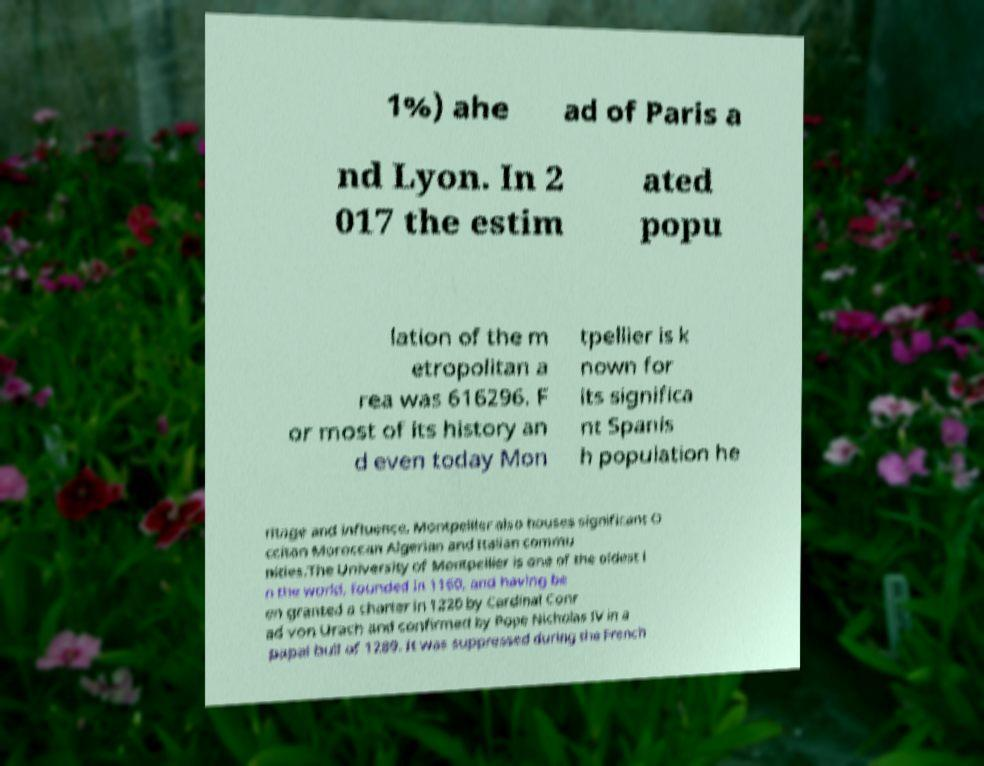For documentation purposes, I need the text within this image transcribed. Could you provide that? 1%) ahe ad of Paris a nd Lyon. In 2 017 the estim ated popu lation of the m etropolitan a rea was 616296. F or most of its history an d even today Mon tpellier is k nown for its significa nt Spanis h population he ritage and influence. Montpellier also houses significant O ccitan Moroccan Algerian and Italian commu nities.The University of Montpellier is one of the oldest i n the world, founded in 1160, and having be en granted a charter in 1220 by Cardinal Conr ad von Urach and confirmed by Pope Nicholas IV in a papal bull of 1289. It was suppressed during the French 